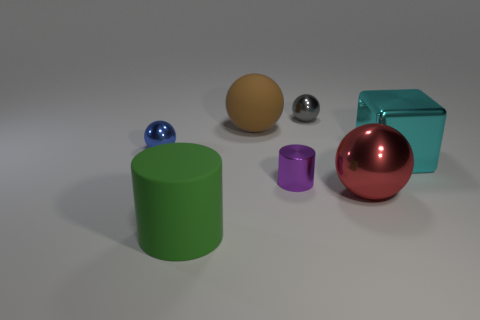Add 3 brown balls. How many objects exist? 10 Subtract all blocks. How many objects are left? 6 Add 4 big brown spheres. How many big brown spheres are left? 5 Add 2 cyan cubes. How many cyan cubes exist? 3 Subtract 1 gray spheres. How many objects are left? 6 Subtract all large gray cylinders. Subtract all cylinders. How many objects are left? 5 